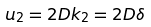<formula> <loc_0><loc_0><loc_500><loc_500>u _ { 2 } = 2 D k _ { 2 } = 2 D \delta</formula> 